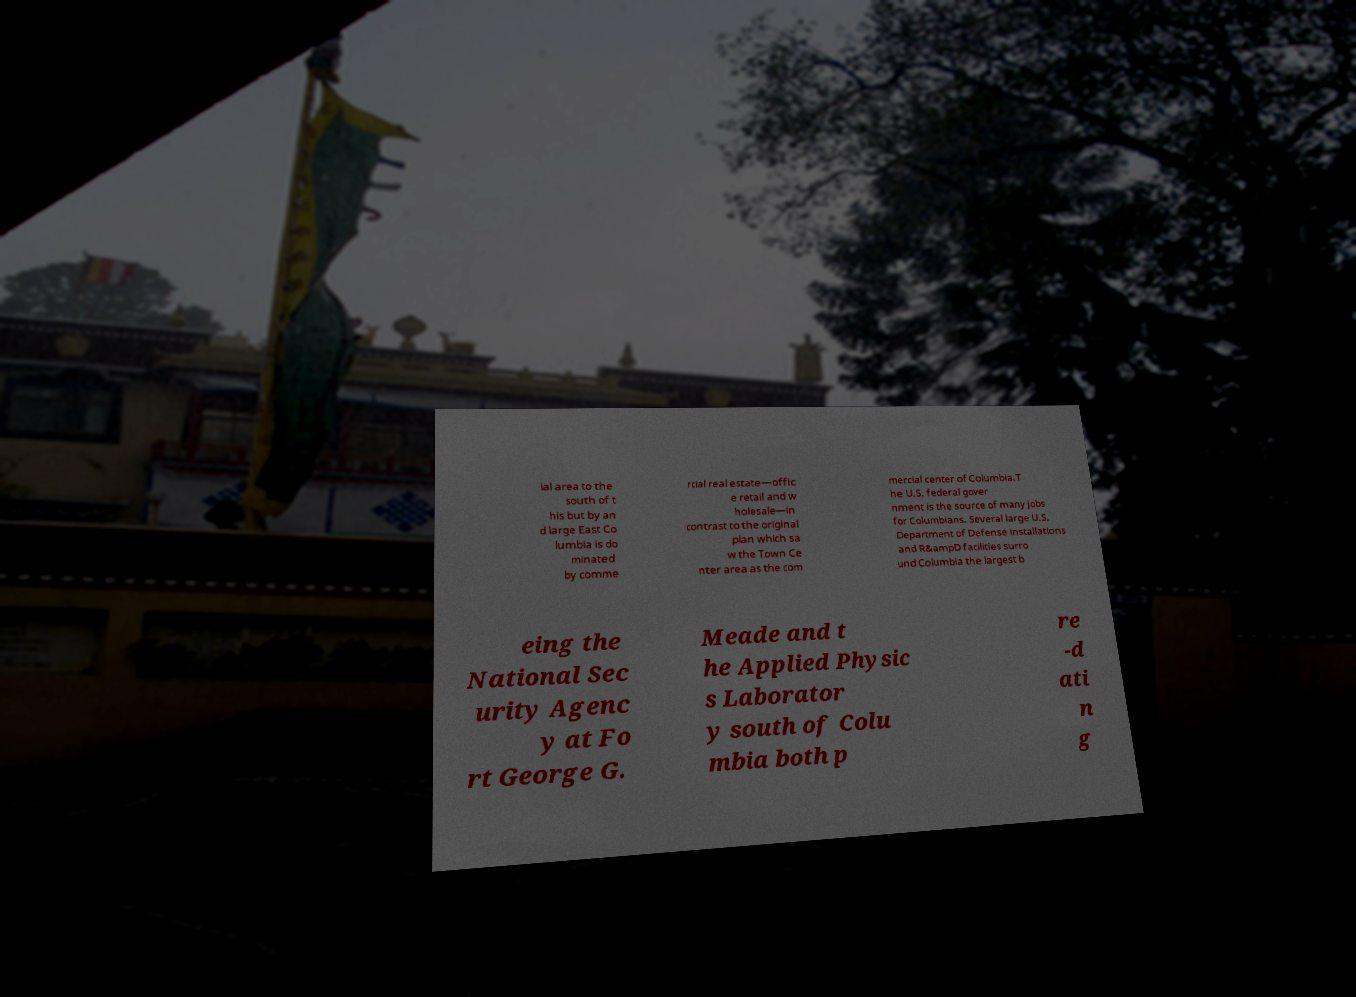Could you assist in decoding the text presented in this image and type it out clearly? ial area to the south of t his but by an d large East Co lumbia is do minated by comme rcial real estate—offic e retail and w holesale—in contrast to the original plan which sa w the Town Ce nter area as the com mercial center of Columbia.T he U.S. federal gover nment is the source of many jobs for Columbians. Several large U.S. Department of Defense installations and R&ampD facilities surro und Columbia the largest b eing the National Sec urity Agenc y at Fo rt George G. Meade and t he Applied Physic s Laborator y south of Colu mbia both p re -d ati n g 